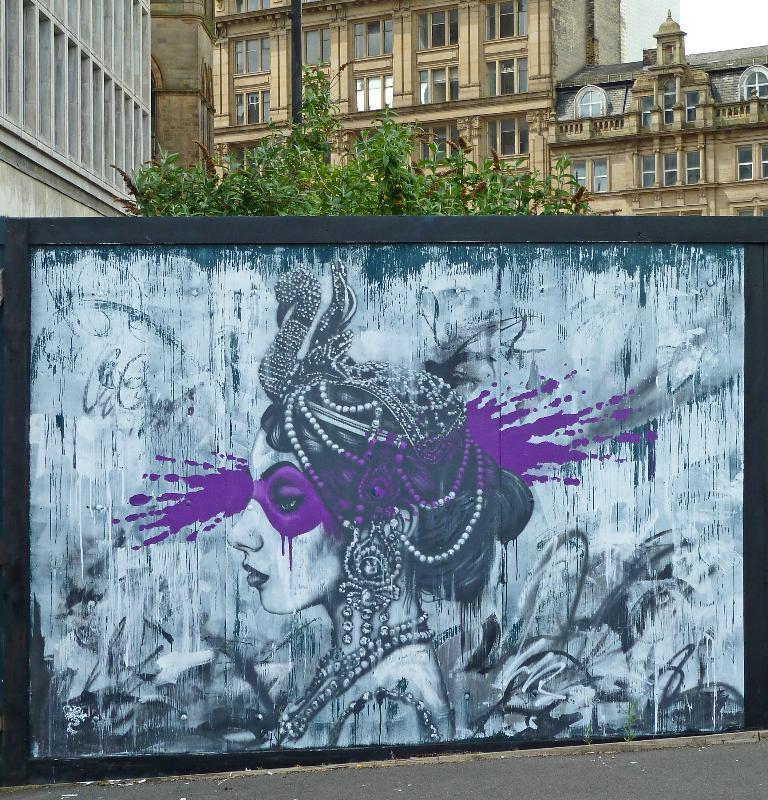Can you describe this image briefly? In the foreground I can see a wall painting on the road. In the background I can see trees, buildings, windows and the sky. This image is taken may be on the road. 